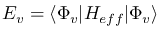Convert formula to latex. <formula><loc_0><loc_0><loc_500><loc_500>\begin{array} { r } { E _ { v } = \langle \Phi _ { v } | H _ { e f f } | \Phi _ { v } \rangle } \end{array}</formula> 